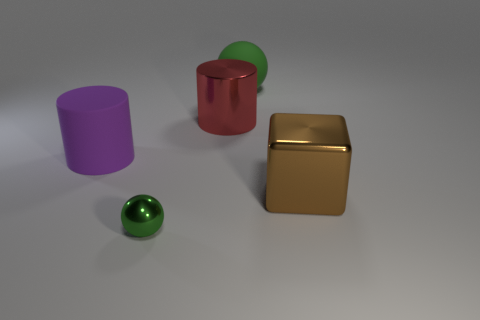Is there anything else that has the same shape as the big green matte thing? Yes, the shape of the big green matte object, which is a cylinder, is shared by the smaller red glossy object; they both have circular bases and straight sides, characteristic of cylinders. 